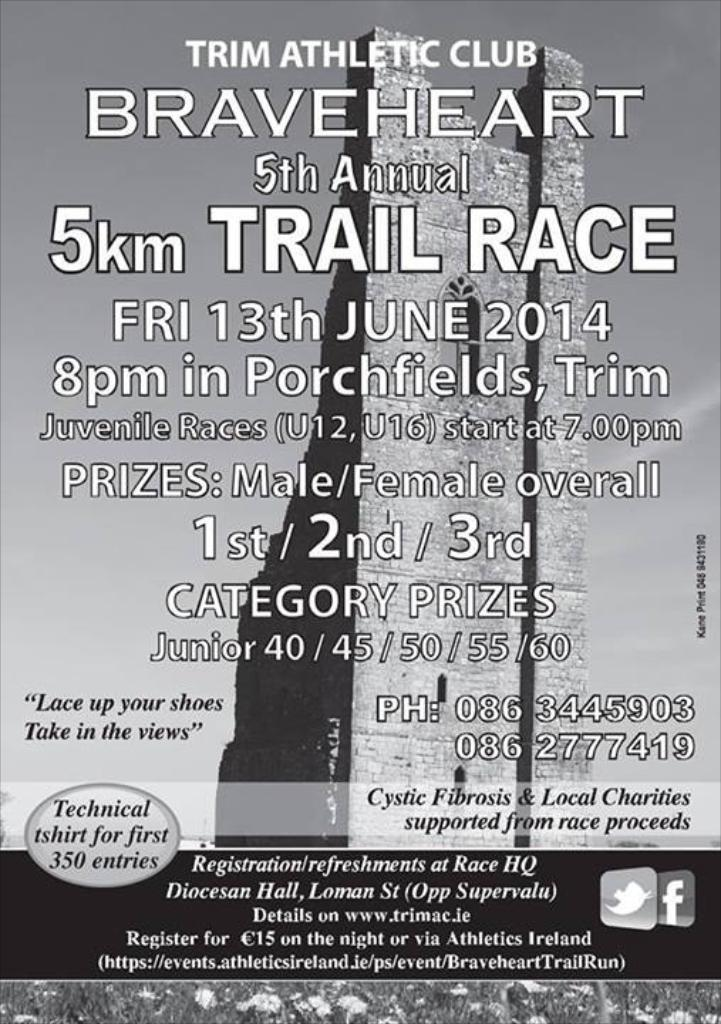Provide a one-sentence caption for the provided image. A poster advertises the Trim Athletic Club Braveheart 5th Annual 5km Trail Race on Friday, June 13 2014. 